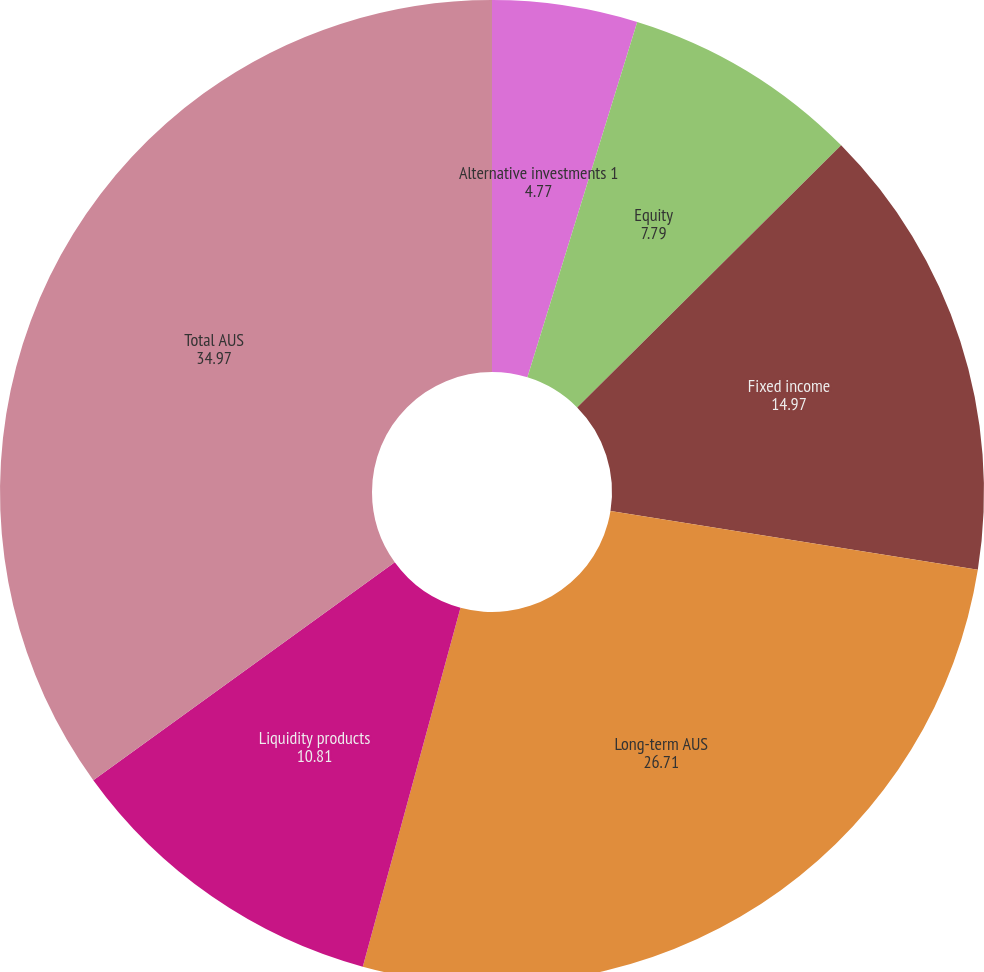<chart> <loc_0><loc_0><loc_500><loc_500><pie_chart><fcel>Alternative investments 1<fcel>Equity<fcel>Fixed income<fcel>Long-term AUS<fcel>Liquidity products<fcel>Total AUS<nl><fcel>4.77%<fcel>7.79%<fcel>14.97%<fcel>26.71%<fcel>10.81%<fcel>34.97%<nl></chart> 